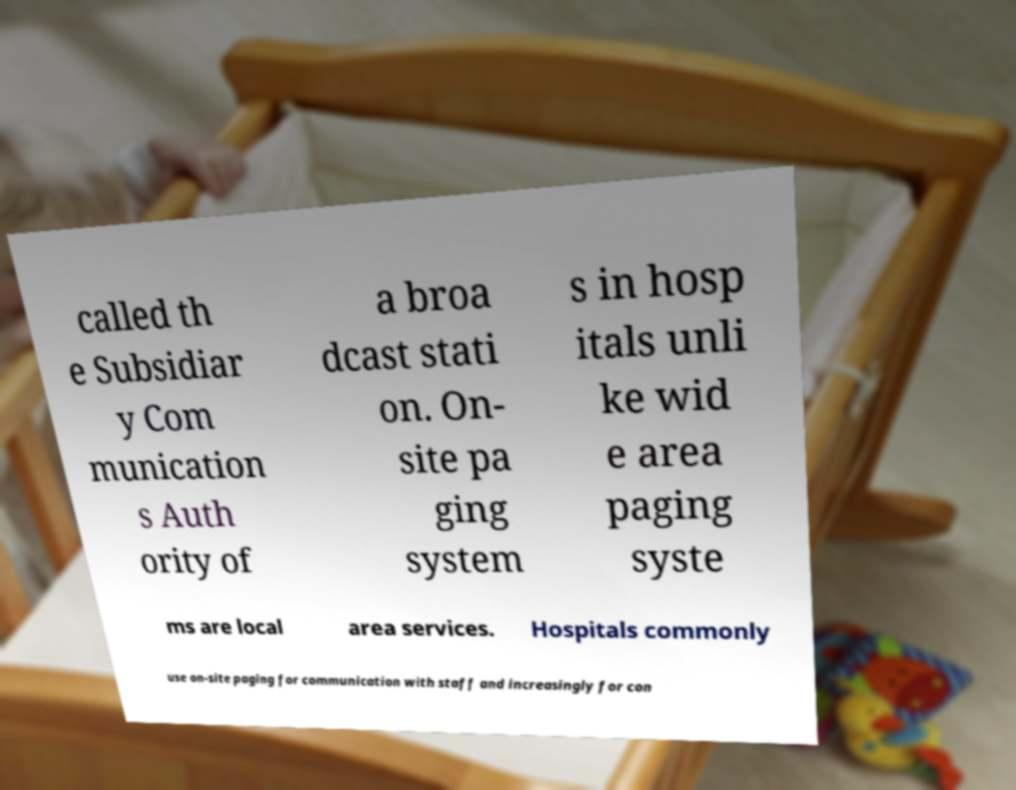What messages or text are displayed in this image? I need them in a readable, typed format. called th e Subsidiar y Com munication s Auth ority of a broa dcast stati on. On- site pa ging system s in hosp itals unli ke wid e area paging syste ms are local area services. Hospitals commonly use on-site paging for communication with staff and increasingly for con 